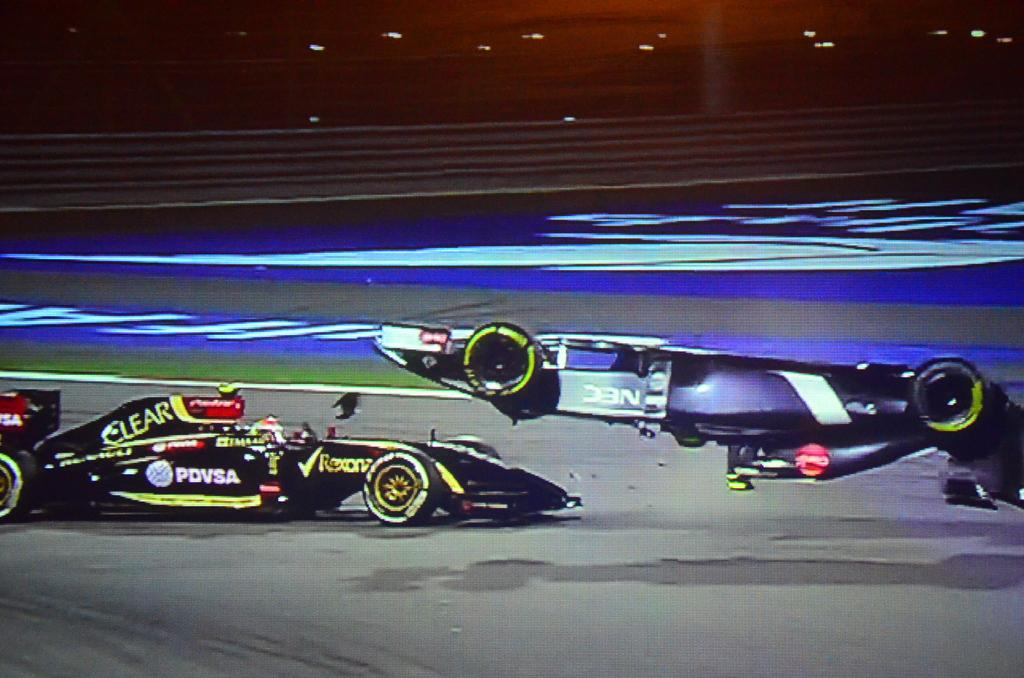<image>
Offer a succinct explanation of the picture presented. One of the two race cars is black and has the word Clear on it 